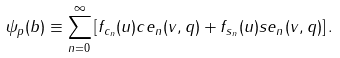<formula> <loc_0><loc_0><loc_500><loc_500>\psi _ { p } ( { b } ) \equiv \sum _ { n = 0 } ^ { \infty } \left [ f _ { c _ { n } } ( u ) c e _ { n } ( v , q ) + f _ { s _ { n } } ( u ) s e _ { n } ( v , q ) \right ] .</formula> 